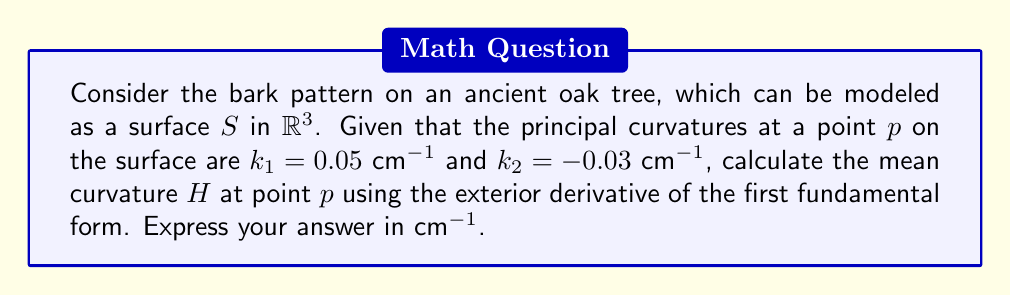Can you answer this question? To solve this problem, we'll follow these steps:

1) Recall that the mean curvature $H$ is defined as the average of the principal curvatures:

   $$H = \frac{k_1 + k_2}{2}$$

2) We're given the principal curvatures:
   $k_1 = 0.05$ cm^(-1)
   $k_2 = -0.03$ cm^(-1)

3) Substitute these values into the formula:

   $$H = \frac{0.05 + (-0.03)}{2}$$

4) Simplify:
   $$H = \frac{0.02}{2} = 0.01\text{ cm}^{-1}$$

5) While we calculated $H$ directly here, it's worth noting that in differential geometry, we can also express the mean curvature using differential forms. The first fundamental form $I$ is given by:

   $$I = E\,du^2 + 2F\,du\,dv + G\,dv^2$$

   where $E$, $F$, and $G$ are coefficients of the first fundamental form.

6) The mean curvature can be related to the exterior derivative of $I$, but the direct calculation as we've done here is more straightforward for given principal curvatures.
Answer: $0.01\text{ cm}^{-1}$ 